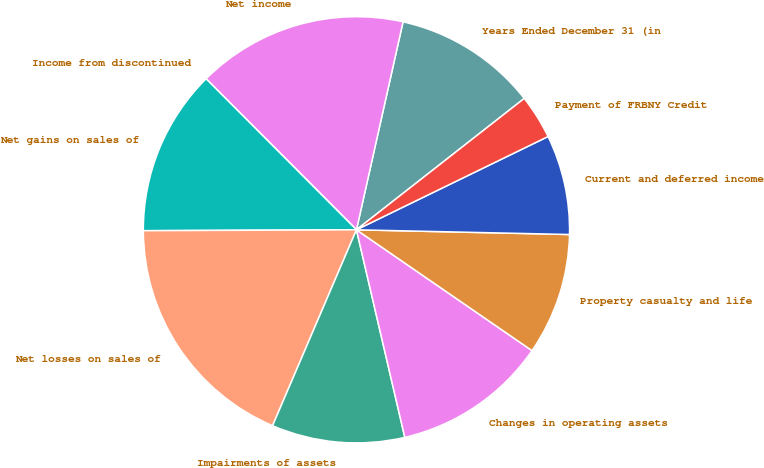Convert chart to OTSL. <chart><loc_0><loc_0><loc_500><loc_500><pie_chart><fcel>Years Ended December 31 (in<fcel>Net income<fcel>Income from discontinued<fcel>Net gains on sales of<fcel>Net losses on sales of<fcel>Impairments of assets<fcel>Changes in operating assets<fcel>Property casualty and life<fcel>Current and deferred income<fcel>Payment of FRBNY Credit<nl><fcel>10.92%<fcel>15.97%<fcel>0.0%<fcel>12.6%<fcel>18.49%<fcel>10.08%<fcel>11.76%<fcel>9.24%<fcel>7.56%<fcel>3.36%<nl></chart> 